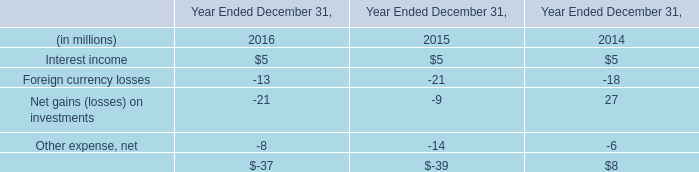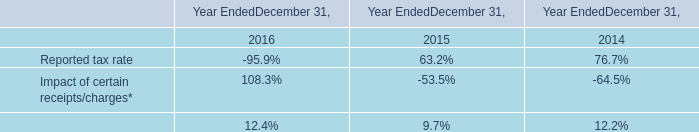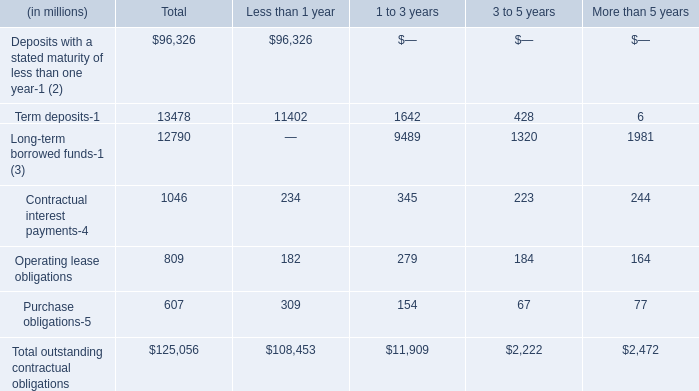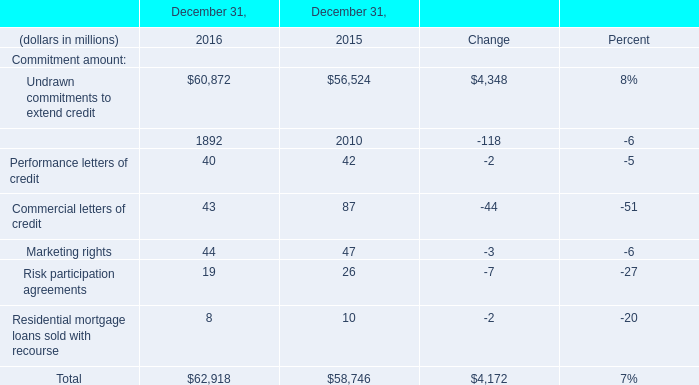Which year/section is Undrawn commitments to extend credit the most? 
Answer: 2016. 